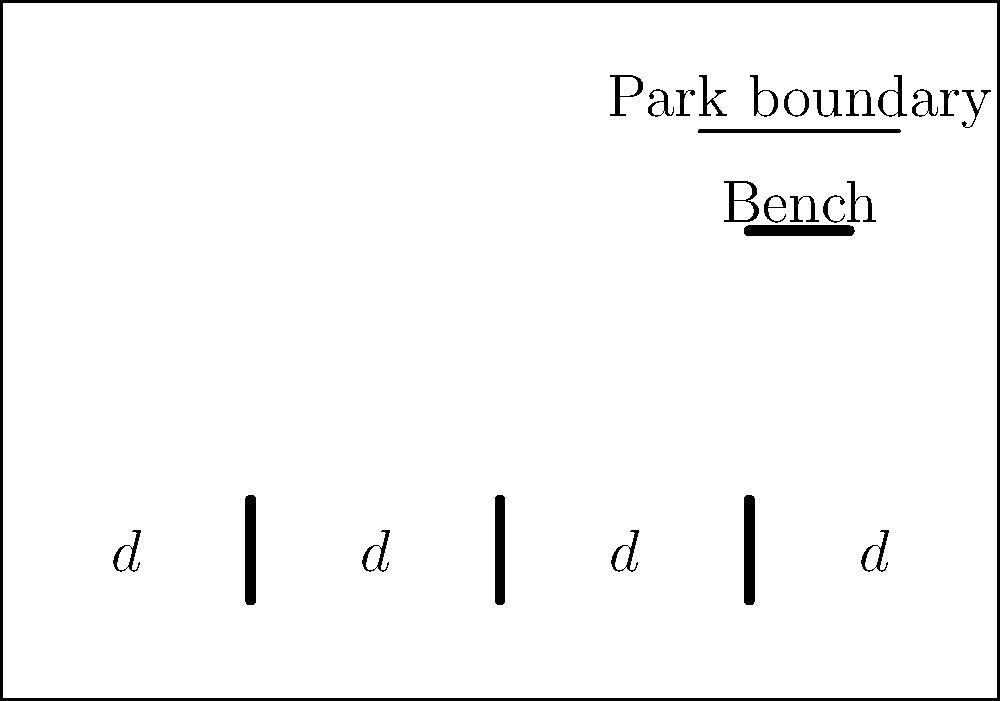In designing an inclusive public park, you need to determine the optimal spacing between benches. The park is rectangular, measuring 100 meters in length. If you want to place 5 benches along the length of the park with equal spacing between them and from the park boundaries, what should be the distance $d$ (in meters) between each bench and between the end benches and the park boundaries? To calculate the optimal spacing between benches for an inclusive park design, we can follow these steps:

1. Understand the given information:
   - The park is 100 meters long
   - We need to place 5 benches
   - The spacing should be equal between benches and from the boundaries

2. Visualize the problem:
   - The park length can be divided into 6 equal segments
   - These segments represent the 5 spaces between benches and the 2 end spaces

3. Set up the equation:
   - Let $d$ be the distance between benches and from the boundaries
   - Total length = Number of segments × Distance per segment
   - 100 = 6d

4. Solve for $d$:
   $$100 = 6d$$
   $$d = \frac{100}{6}$$
   $$d = 16.67 \text{ meters}$$

5. Round to two decimal places for practical application:
   $d \approx 16.67 \text{ meters}$

This spacing ensures equal accessibility for all park visitors, promoting inclusivity by providing regular resting spots throughout the park's length.
Answer: 16.67 meters 